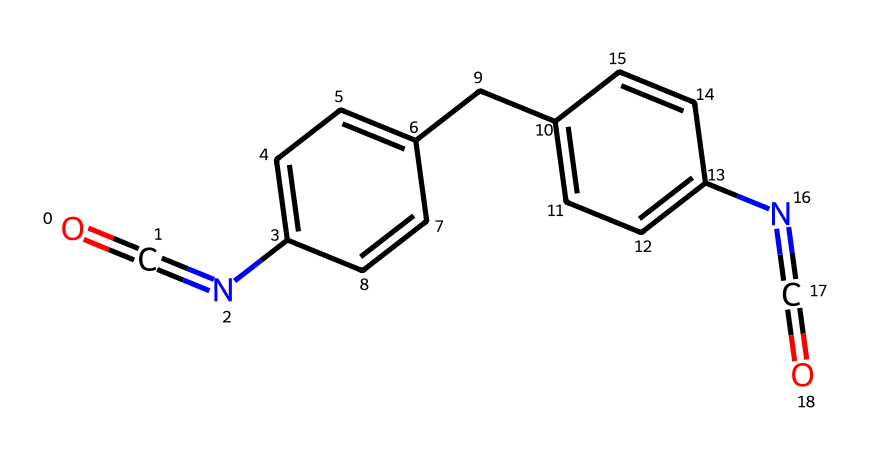What functional groups are present in this structure? The structure includes an isocyanate group (N=C=O) and amine groups (N). Isocyanates are characterized by the presence of -N=C=O, while amines contain -NH2 or similar. Both are visible in the SMILES representation.
Answer: isocyanate, amine How many carbon atoms are in this chemical? By interpreting the SMILES representation, we can count the carbon (C) atoms directly from the structure. There are six carbons in the aromatic rings and three additional from the alkane part, leading to a total of nine.
Answer: 9 What type of polymerization reaction is associated with this monomer? The presence of isocyanate groups indicates that this monomer is involved in step-growth polymerization, specifically forming polyurethanes through reactions with polyols.
Answer: step-growth polymerization What is the primary use of the product made from this monomer? The primary use is in making flexible polyurethane foam, which is widely used in applications such as seat cushions, including those in stadiums.
Answer: seat cushions What role do the amine groups play in the polymer formation? The amine groups can react with the isocyanate groups to form urea linkages, which are essential for building the polymer backbone in polyurethanes. This reaction impacts the flexibility and strength of the foam.
Answer: form urea linkages 